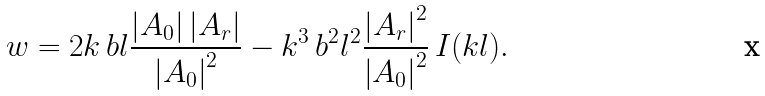Convert formula to latex. <formula><loc_0><loc_0><loc_500><loc_500>w = 2 k \, b l \frac { \left | A _ { 0 } \right | \left | A _ { r } \right | } { \left | A _ { 0 } \right | ^ { 2 } } - k ^ { 3 } \, b ^ { 2 } l ^ { 2 } \frac { \left | A _ { r } \right | ^ { 2 } } { \left | A _ { 0 } \right | ^ { 2 } } \, I ( k l ) .</formula> 